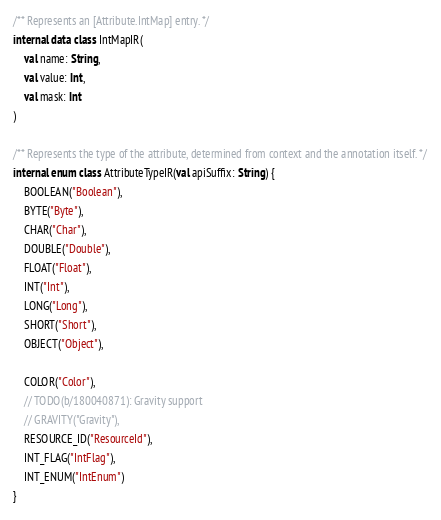Convert code to text. <code><loc_0><loc_0><loc_500><loc_500><_Kotlin_>
/** Represents an [Attribute.IntMap] entry. */
internal data class IntMapIR(
    val name: String,
    val value: Int,
    val mask: Int
)

/** Represents the type of the attribute, determined from context and the annotation itself. */
internal enum class AttributeTypeIR(val apiSuffix: String) {
    BOOLEAN("Boolean"),
    BYTE("Byte"),
    CHAR("Char"),
    DOUBLE("Double"),
    FLOAT("Float"),
    INT("Int"),
    LONG("Long"),
    SHORT("Short"),
    OBJECT("Object"),

    COLOR("Color"),
    // TODO(b/180040871): Gravity support
    // GRAVITY("Gravity"),
    RESOURCE_ID("ResourceId"),
    INT_FLAG("IntFlag"),
    INT_ENUM("IntEnum")
}
</code> 